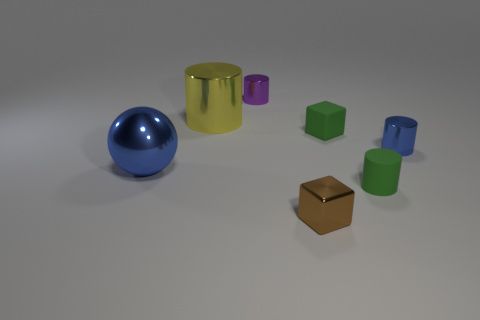What materials might these objects be made of, based on their appearance? Based on the appearance of the objects in the image, the sphere and the cylinders exhibit a reflective surface that suggests they could be made of a polished metal or a similarly reflective material. The cubes, with their matte finish, might consist of a plastic or painted wood. 